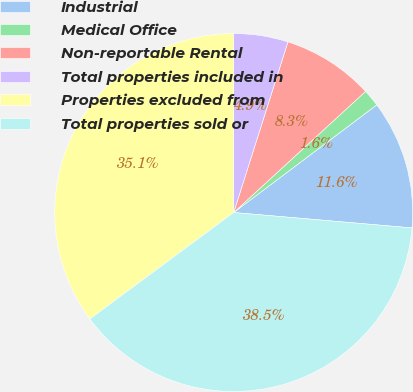Convert chart to OTSL. <chart><loc_0><loc_0><loc_500><loc_500><pie_chart><fcel>Industrial<fcel>Medical Office<fcel>Non-reportable Rental<fcel>Total properties included in<fcel>Properties excluded from<fcel>Total properties sold or<nl><fcel>11.64%<fcel>1.56%<fcel>8.28%<fcel>4.92%<fcel>35.13%<fcel>38.49%<nl></chart> 